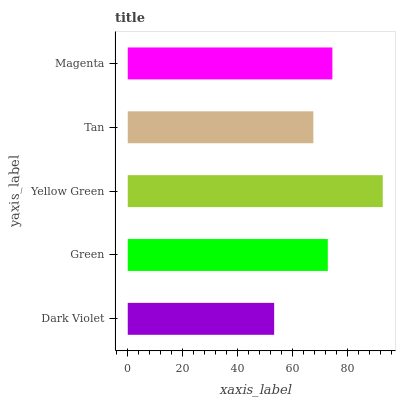Is Dark Violet the minimum?
Answer yes or no. Yes. Is Yellow Green the maximum?
Answer yes or no. Yes. Is Green the minimum?
Answer yes or no. No. Is Green the maximum?
Answer yes or no. No. Is Green greater than Dark Violet?
Answer yes or no. Yes. Is Dark Violet less than Green?
Answer yes or no. Yes. Is Dark Violet greater than Green?
Answer yes or no. No. Is Green less than Dark Violet?
Answer yes or no. No. Is Green the high median?
Answer yes or no. Yes. Is Green the low median?
Answer yes or no. Yes. Is Dark Violet the high median?
Answer yes or no. No. Is Yellow Green the low median?
Answer yes or no. No. 